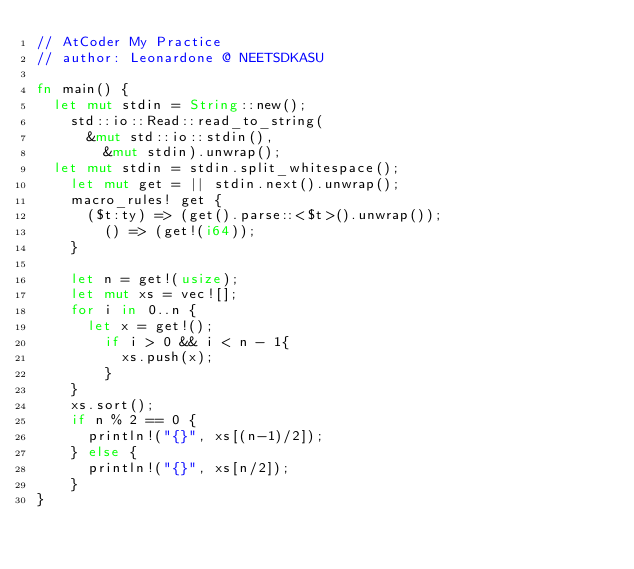<code> <loc_0><loc_0><loc_500><loc_500><_Rust_>// AtCoder My Practice
// author: Leonardone @ NEETSDKASU

fn main() {
	let mut stdin = String::new();
    std::io::Read::read_to_string(
    	&mut std::io::stdin(),
        &mut stdin).unwrap();
	let mut stdin = stdin.split_whitespace();
    let mut get = || stdin.next().unwrap();
    macro_rules! get {
    	($t:ty) => (get().parse::<$t>().unwrap());
        () => (get!(i64));
    }
    
    let n = get!(usize);
    let mut xs = vec![];
    for i in 0..n {
    	let x = get!();
        if i > 0 && i < n - 1{
        	xs.push(x);
        }
    }
    xs.sort();
    if n % 2 == 0 {
    	println!("{}", xs[(n-1)/2]);
    } else {
    	println!("{}", xs[n/2]);
    }
}</code> 